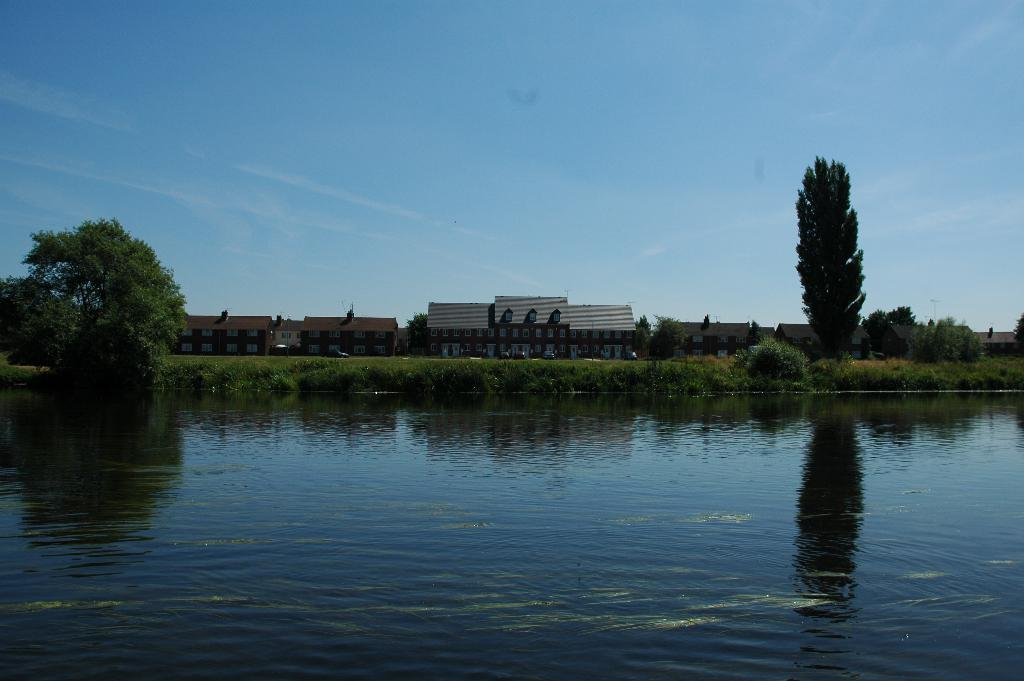What is one of the natural elements present in the image? There is water in the image. What type of vegetation can be seen in the image? There is grass and trees in the image. What can be seen in the background of the image? There are buildings and the sky visible in the background of the image. What type of cough can be heard coming from the trees in the image? There is no sound, such as a cough, present in the image. The image only shows a visual representation of the scene, which includes water, grass, trees, buildings, and the sky. 